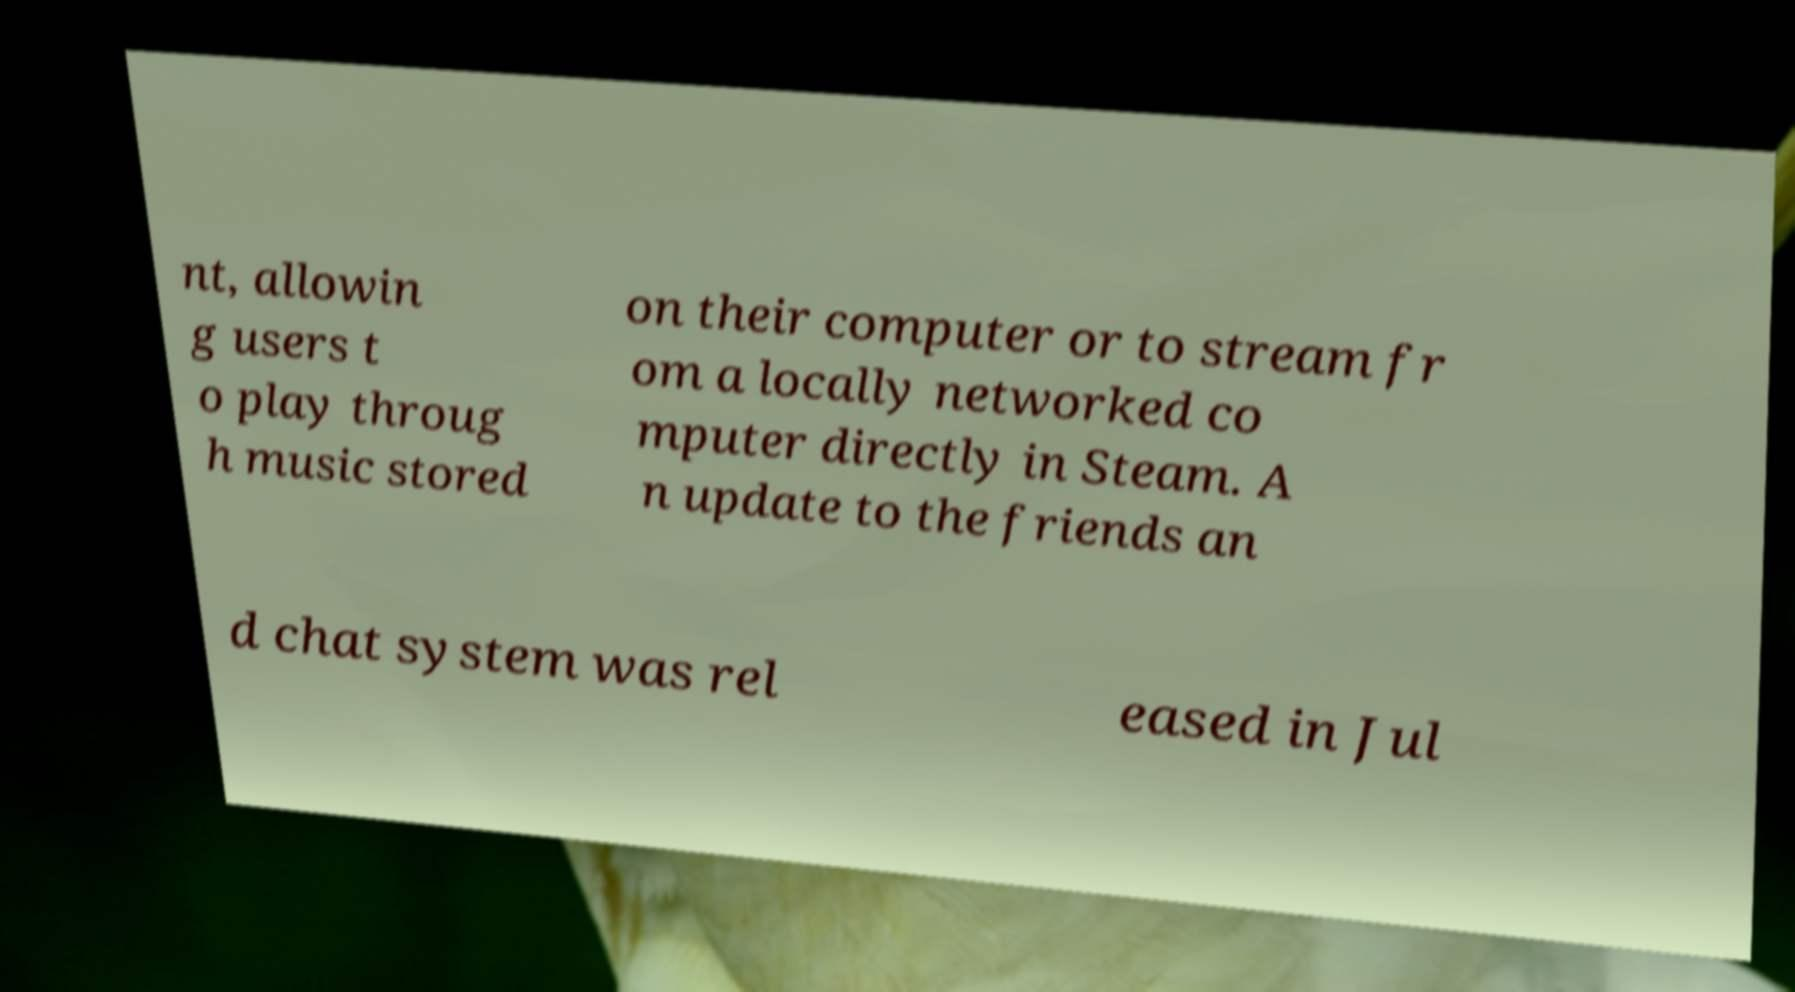Could you extract and type out the text from this image? nt, allowin g users t o play throug h music stored on their computer or to stream fr om a locally networked co mputer directly in Steam. A n update to the friends an d chat system was rel eased in Jul 